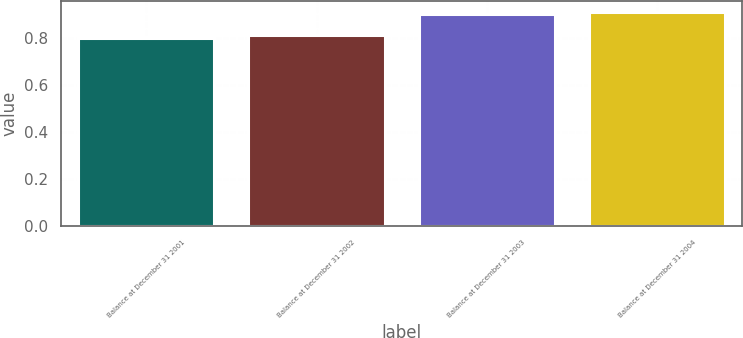Convert chart to OTSL. <chart><loc_0><loc_0><loc_500><loc_500><bar_chart><fcel>Balance at December 31 2001<fcel>Balance at December 31 2002<fcel>Balance at December 31 2003<fcel>Balance at December 31 2004<nl><fcel>0.8<fcel>0.81<fcel>0.9<fcel>0.91<nl></chart> 